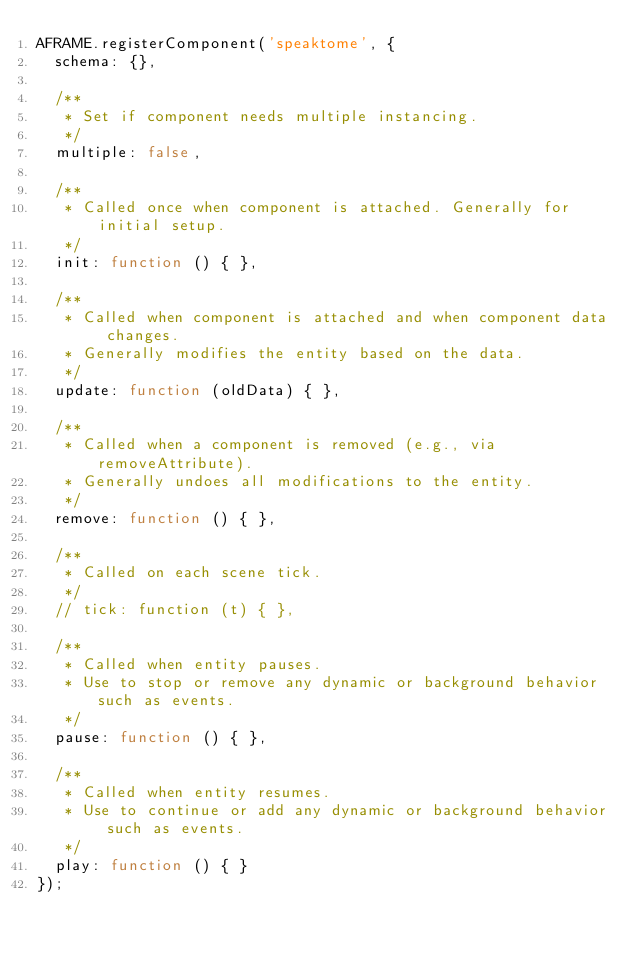Convert code to text. <code><loc_0><loc_0><loc_500><loc_500><_JavaScript_>AFRAME.registerComponent('speaktome', {
  schema: {},

  /**
   * Set if component needs multiple instancing.
   */
  multiple: false,

  /**
   * Called once when component is attached. Generally for initial setup.
   */
  init: function () { },

  /**
   * Called when component is attached and when component data changes.
   * Generally modifies the entity based on the data.
   */
  update: function (oldData) { },

  /**
   * Called when a component is removed (e.g., via removeAttribute).
   * Generally undoes all modifications to the entity.
   */
  remove: function () { },

  /**
   * Called on each scene tick.
   */
  // tick: function (t) { },

  /**
   * Called when entity pauses.
   * Use to stop or remove any dynamic or background behavior such as events.
   */
  pause: function () { },

  /**
   * Called when entity resumes.
   * Use to continue or add any dynamic or background behavior such as events.
   */
  play: function () { }
});
</code> 